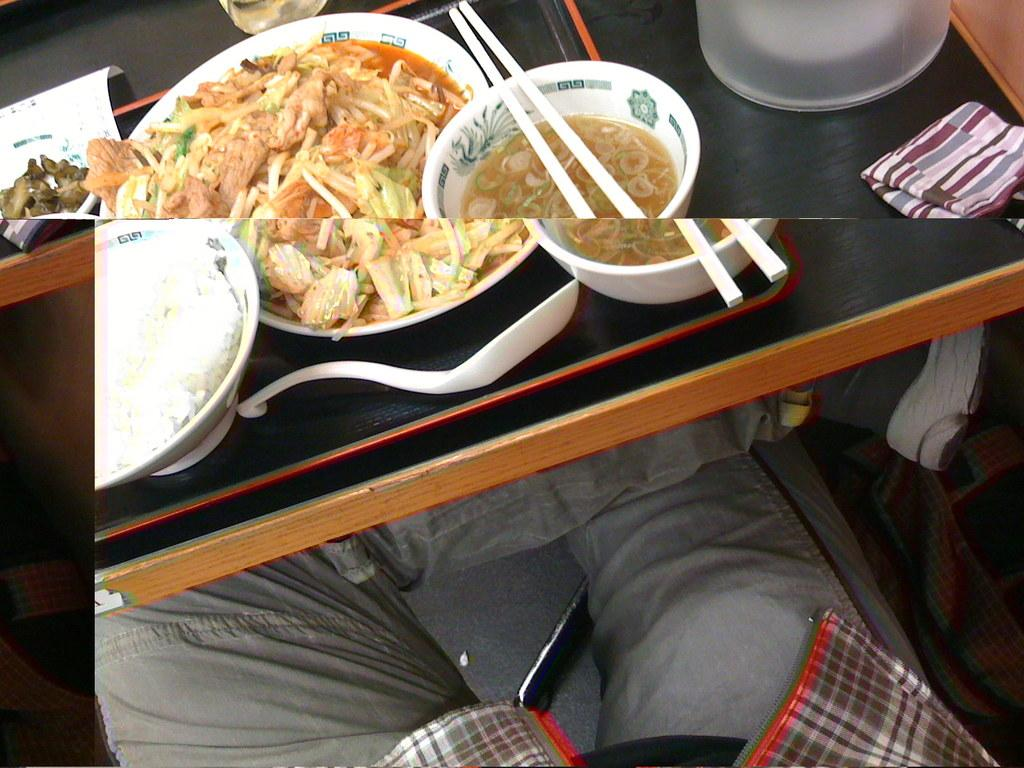What is the primary subject of the image? Food is the main focus of the image. What type of containers are on the table? There are bowls on the table. What utensils are present on the table? Spoons and chopsticks are present on the table. What else can be seen on the table? Plates are visible on the table. Is there a person in the image? Yes, a person is sitting on a chair in the image. What type of heat-generating apparatus is being used toasted by the rabbits in the image? There are no rabbits or heat-generating apparatus present in the image. 